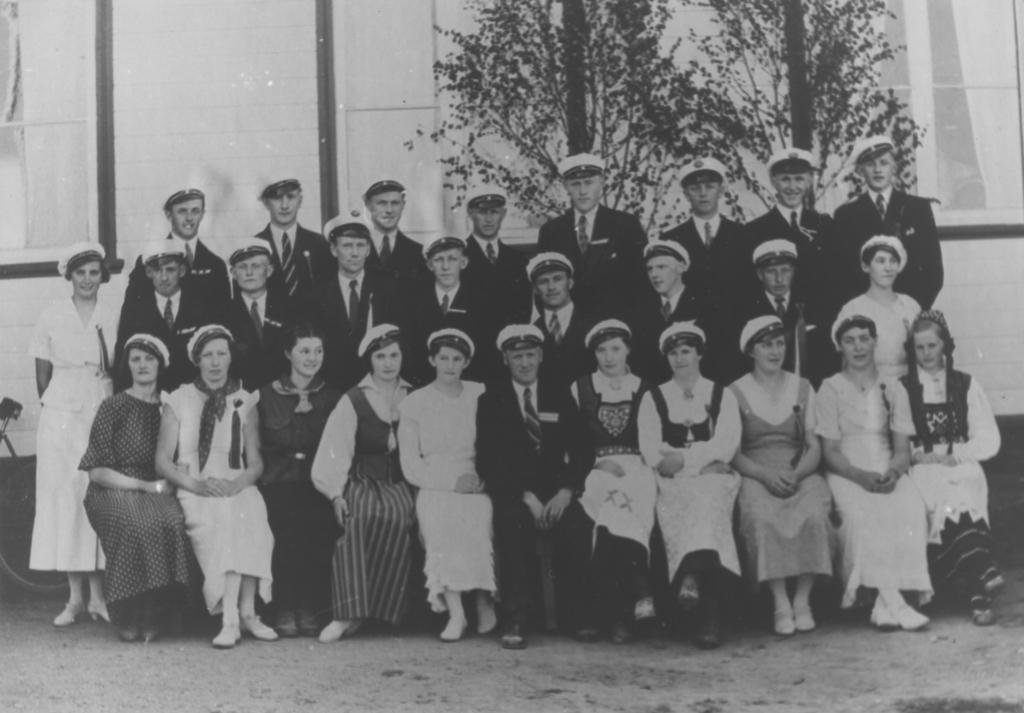Describe this image in one or two sentences. This is a black and white image. Here I can see a crowd of people are giving pose for the picture. In the front I can see few women at sitting on the bench, at the back men are standing. In the background there are two trees and a wall along with the glass. 